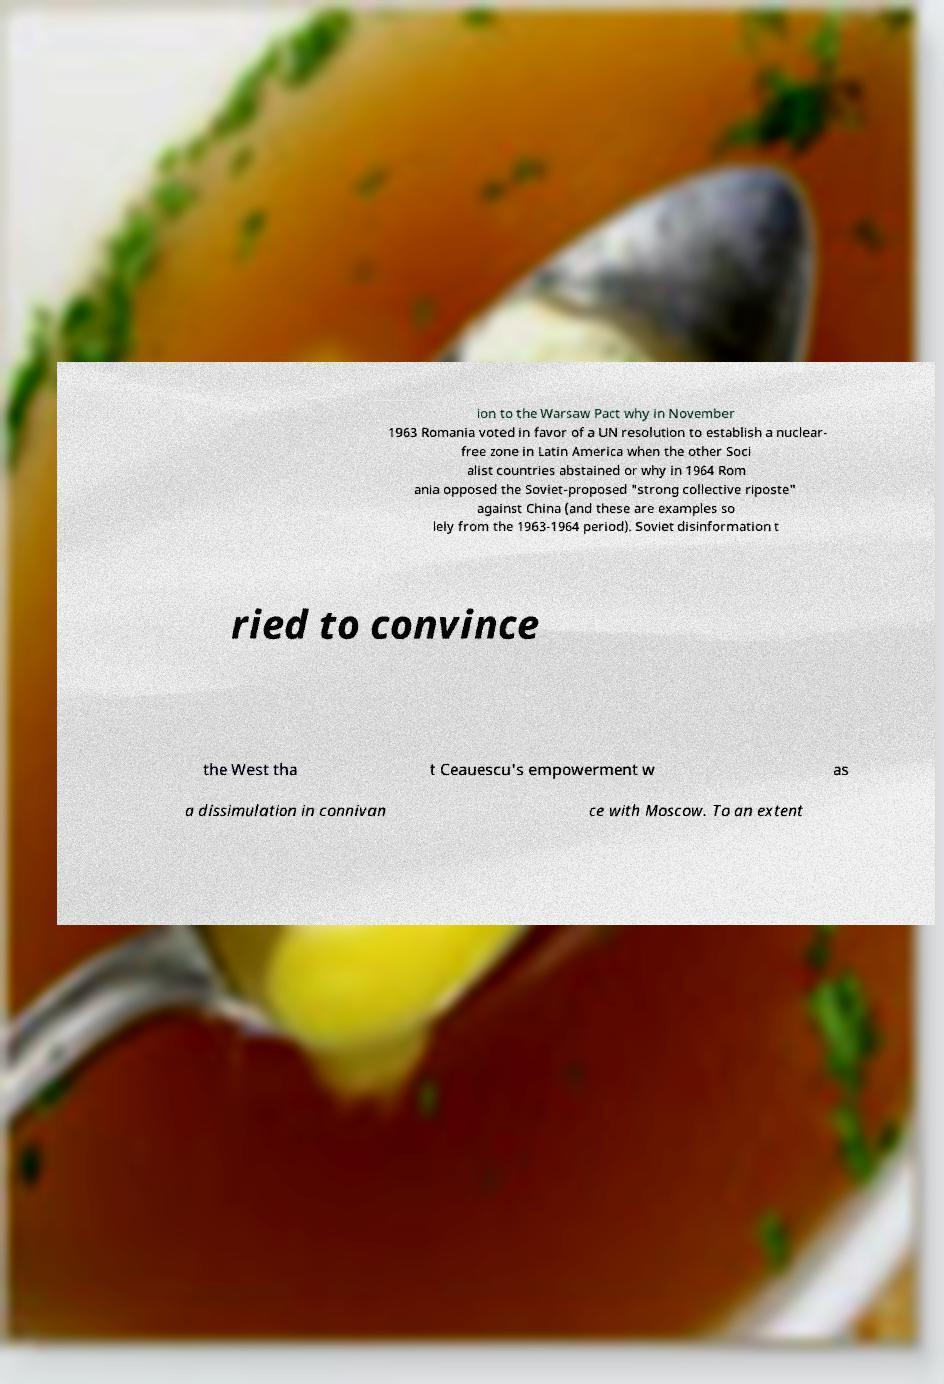I need the written content from this picture converted into text. Can you do that? ion to the Warsaw Pact why in November 1963 Romania voted in favor of a UN resolution to establish a nuclear- free zone in Latin America when the other Soci alist countries abstained or why in 1964 Rom ania opposed the Soviet-proposed "strong collective riposte" against China (and these are examples so lely from the 1963-1964 period). Soviet disinformation t ried to convince the West tha t Ceauescu's empowerment w as a dissimulation in connivan ce with Moscow. To an extent 